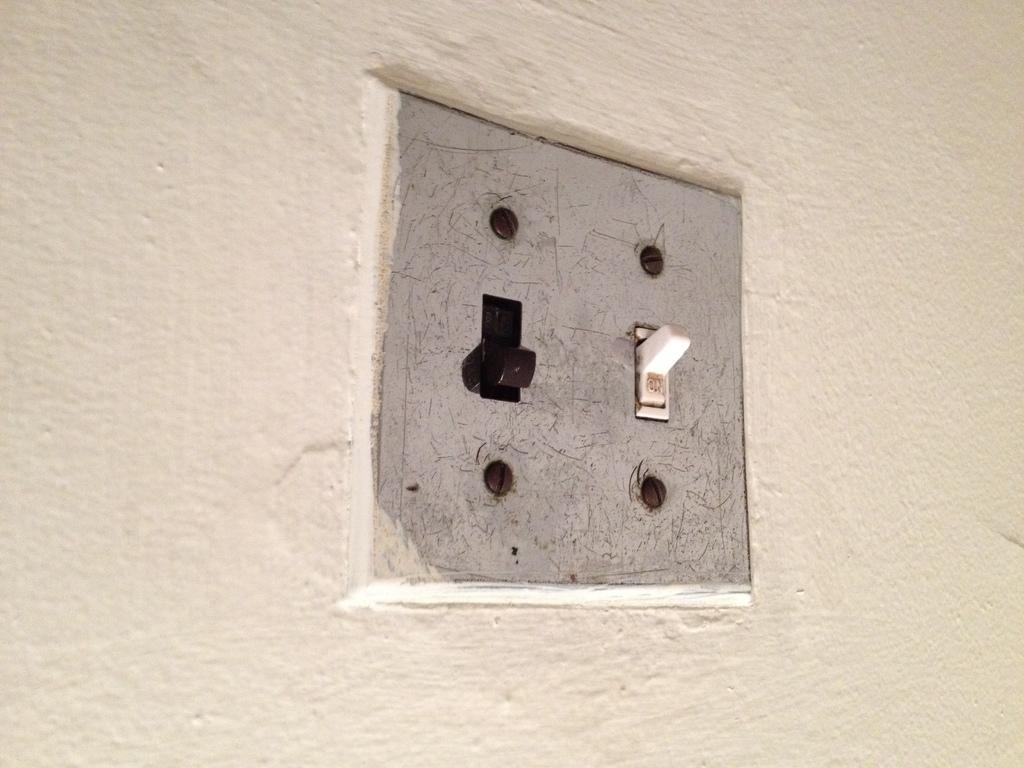What object is present in the image that is used for connecting electrical devices? There is a socket in the image that is used for connecting electrical devices. Where is the socket located in the image? The socket is in the wall. What color is the socket in the image? The socket is black and white in color. Can you see any fairies flying around the socket in the image? No, there are no fairies present in the image. Is there a snail crawling on the socket in the image? No, there is no snail present in the image. 